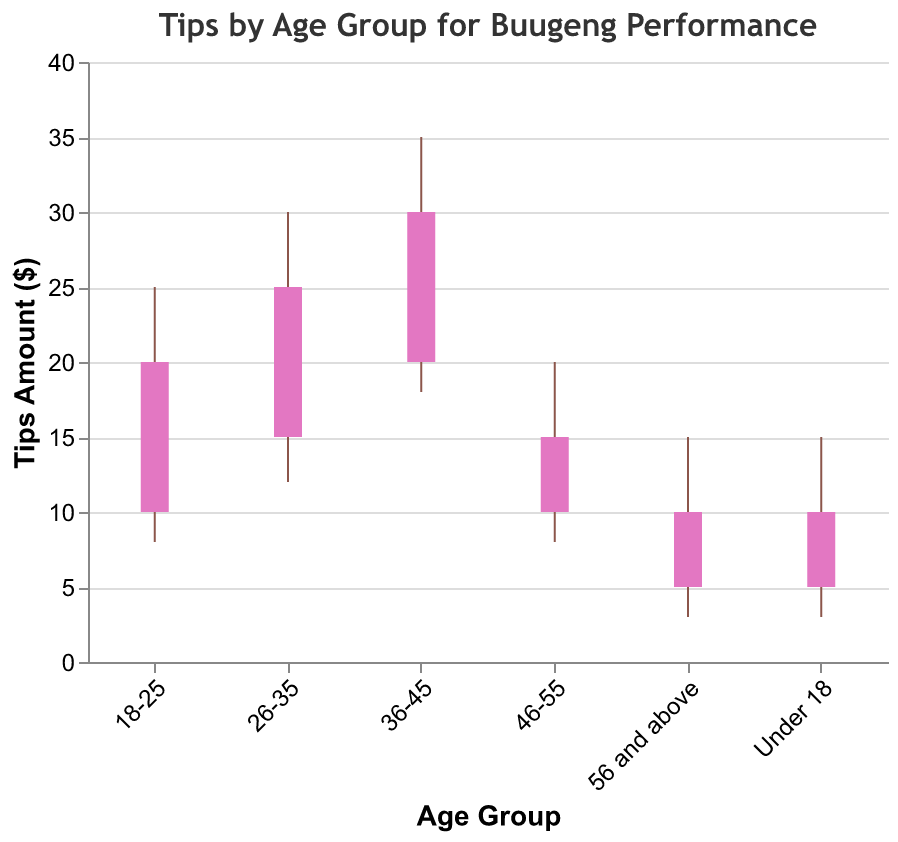What's the title of the figure? The title is typically found at the top of the figure and provides a brief description of what the figure is about.
Answer: Tips by Age Group for Buugeng Performance What does the y-axis represent? The label on the y-axis of the figure indicates what is being measured. In this case, it tells us the unit and what it refers to.
Answer: Tips Amount ($) Which age group has the highest tip amount recorded? To find the highest tip amount, we look for the data point with the highest "High" value on the figure. The age group 36-45 has the highest quantity.
Answer: 36-45 What is the range of tips collected for the age group 18-25? The range of tips is determined by subtracting the lowest value from the highest value in the age group. For the 18-25 age group, the range is 25 (High) - 8 (Low).
Answer: 17 Which two age groups have the same range of tips amounts? We need to compare the ranges of tips (High - Low) for each age group to find equal values. Both the "Under 18" and "56 and above" age groups have a range of 12 (15-3).
Answer: Under 18, 56 and above What is the difference in the closing tip amounts between the age groups 26-35 and 46-55? To find the difference, we subtract the closing tip amount of 46-55 from 26-35, which is 25 (26-35) - 15 (46-55).
Answer: 10 Which age group has the smallest tip range and what is that range? The age group with the smallest tip range can be found by taking the difference between the High and Low values for each group and finding the minimum. The smallest range is for age groups "Under 18" and "56 and above" with a range of 12.
Answer: Under 18, 56 and above; 12 How many age groups have a closing amount higher than the opening amount? We count the age groups where the Close value is higher than the Open value. This applies to all age groups (Under 18, 18-25, 26-35, 36-45, and 46-55).
Answer: 5 What is the average of the opening tip amounts across all age groups? To find the average, sum up the Open values (5 + 10 + 15 + 20 + 10 + 5) and divide by the number of groups, which is 6. The sum is 65, so the average is 65/6.
Answer: 10.83 